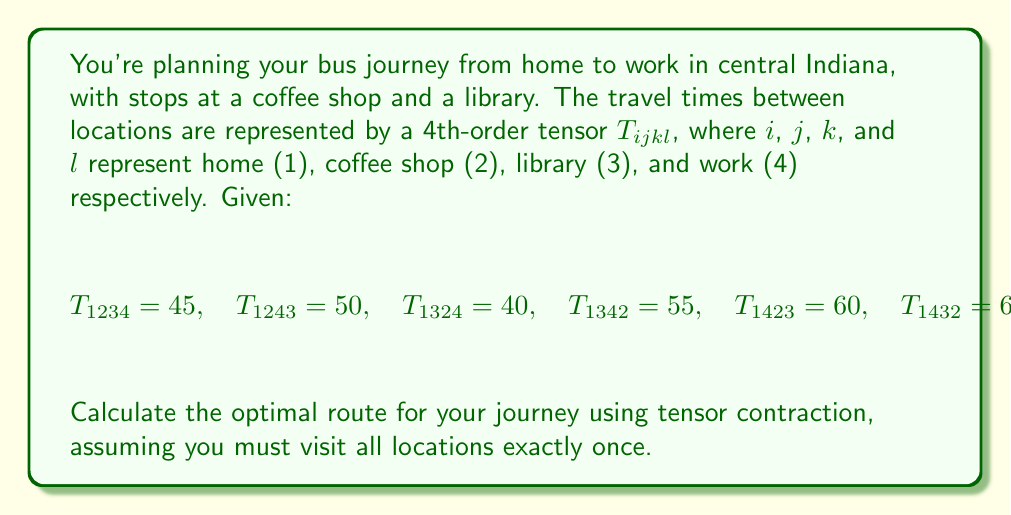Can you solve this math problem? To solve this problem, we'll follow these steps:

1) First, we need to understand what the tensor elements represent. For example, $T_{1234} = 45$ means the total travel time from home (1) to coffee shop (2) to library (3) to work (4) is 45 minutes.

2) We're looking for the minimum travel time among all possible routes. In tensor notation, this can be expressed as:

   $$\min_{(i,j,k) \in P(2,3,4)} T_{1ijk}$$

   where $P(2,3,4)$ represents all permutations of 2, 3, and 4.

3) Let's list all the possible routes and their corresponding travel times:

   Home -> Coffee -> Library -> Work: $T_{1234} = 45$
   Home -> Coffee -> Work -> Library: $T_{1243} = 50$
   Home -> Library -> Coffee -> Work: $T_{1324} = 40$
   Home -> Library -> Work -> Coffee: $T_{1342} = 55$
   Home -> Work -> Coffee -> Library: $T_{1423} = 60$
   Home -> Work -> Library -> Coffee: $T_{1432} = 65$

4) The optimal route is the one with the minimum travel time. From the given values, we can see that $T_{1324} = 40$ is the minimum.

5) Therefore, the optimal route is: Home -> Library -> Coffee -> Work.
Answer: Home -> Library -> Coffee -> Work (40 minutes) 